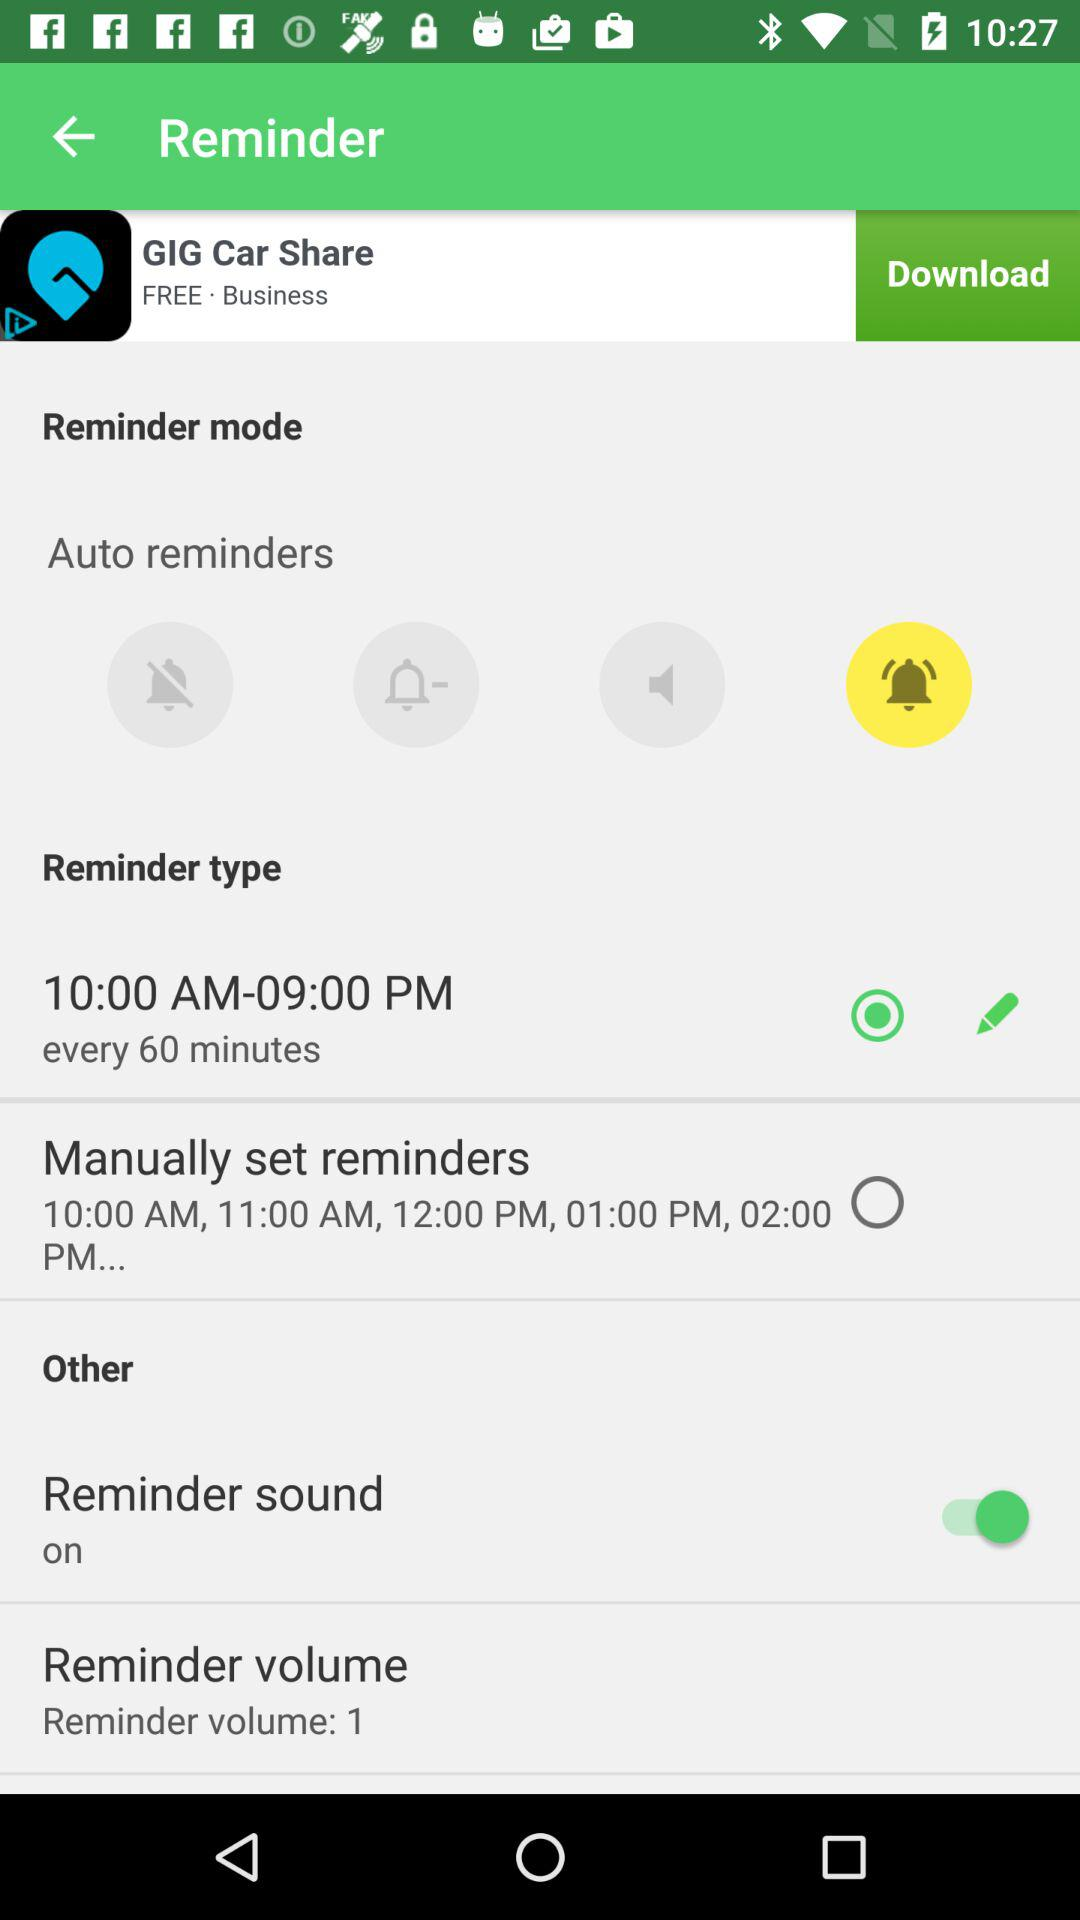What is the status of "Reminder sound"? The status of "Reminder sound" is "on". 